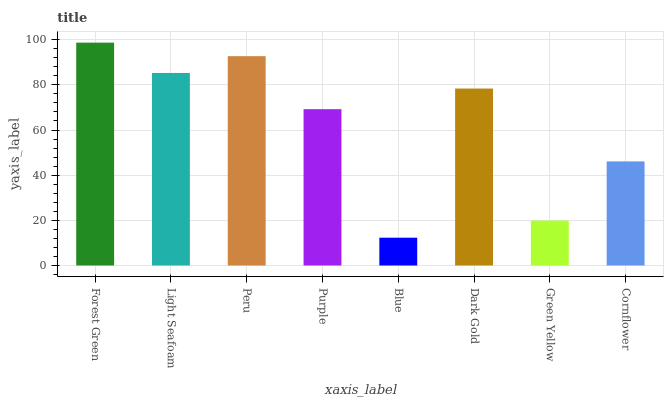Is Light Seafoam the minimum?
Answer yes or no. No. Is Light Seafoam the maximum?
Answer yes or no. No. Is Forest Green greater than Light Seafoam?
Answer yes or no. Yes. Is Light Seafoam less than Forest Green?
Answer yes or no. Yes. Is Light Seafoam greater than Forest Green?
Answer yes or no. No. Is Forest Green less than Light Seafoam?
Answer yes or no. No. Is Dark Gold the high median?
Answer yes or no. Yes. Is Purple the low median?
Answer yes or no. Yes. Is Forest Green the high median?
Answer yes or no. No. Is Green Yellow the low median?
Answer yes or no. No. 